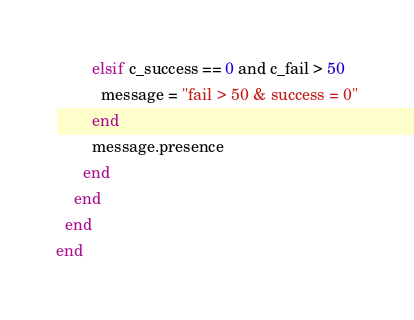<code> <loc_0><loc_0><loc_500><loc_500><_Ruby_>        elsif c_success == 0 and c_fail > 50
          message = "fail > 50 & success = 0"
        end
        message.presence
      end
    end
  end
end</code> 